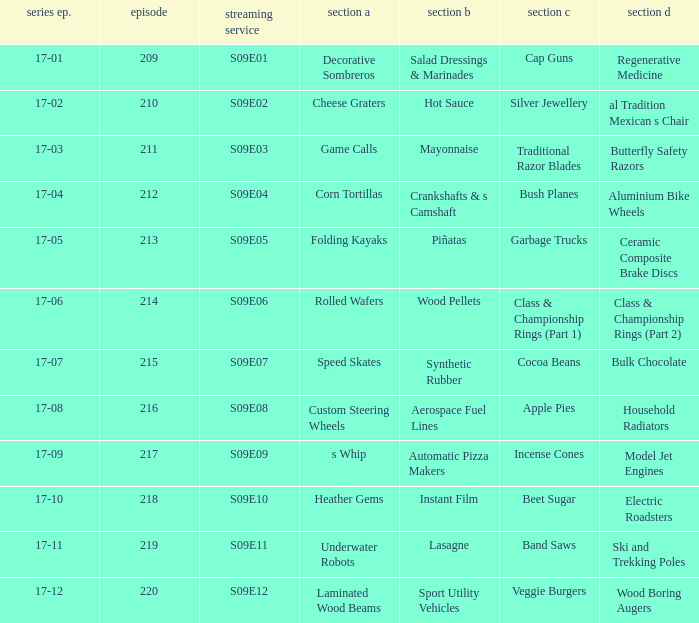Could you help me parse every detail presented in this table? {'header': ['series ep.', 'episode', 'streaming service', 'section a', 'section b', 'section c', 'section d'], 'rows': [['17-01', '209', 'S09E01', 'Decorative Sombreros', 'Salad Dressings & Marinades', 'Cap Guns', 'Regenerative Medicine'], ['17-02', '210', 'S09E02', 'Cheese Graters', 'Hot Sauce', 'Silver Jewellery', 'al Tradition Mexican s Chair'], ['17-03', '211', 'S09E03', 'Game Calls', 'Mayonnaise', 'Traditional Razor Blades', 'Butterfly Safety Razors'], ['17-04', '212', 'S09E04', 'Corn Tortillas', 'Crankshafts & s Camshaft', 'Bush Planes', 'Aluminium Bike Wheels'], ['17-05', '213', 'S09E05', 'Folding Kayaks', 'Piñatas', 'Garbage Trucks', 'Ceramic Composite Brake Discs'], ['17-06', '214', 'S09E06', 'Rolled Wafers', 'Wood Pellets', 'Class & Championship Rings (Part 1)', 'Class & Championship Rings (Part 2)'], ['17-07', '215', 'S09E07', 'Speed Skates', 'Synthetic Rubber', 'Cocoa Beans', 'Bulk Chocolate'], ['17-08', '216', 'S09E08', 'Custom Steering Wheels', 'Aerospace Fuel Lines', 'Apple Pies', 'Household Radiators'], ['17-09', '217', 'S09E09', 's Whip', 'Automatic Pizza Makers', 'Incense Cones', 'Model Jet Engines'], ['17-10', '218', 'S09E10', 'Heather Gems', 'Instant Film', 'Beet Sugar', 'Electric Roadsters'], ['17-11', '219', 'S09E11', 'Underwater Robots', 'Lasagne', 'Band Saws', 'Ski and Trekking Poles'], ['17-12', '220', 'S09E12', 'Laminated Wood Beams', 'Sport Utility Vehicles', 'Veggie Burgers', 'Wood Boring Augers']]} How many segments involve wood boring augers Laminated Wood Beams. 